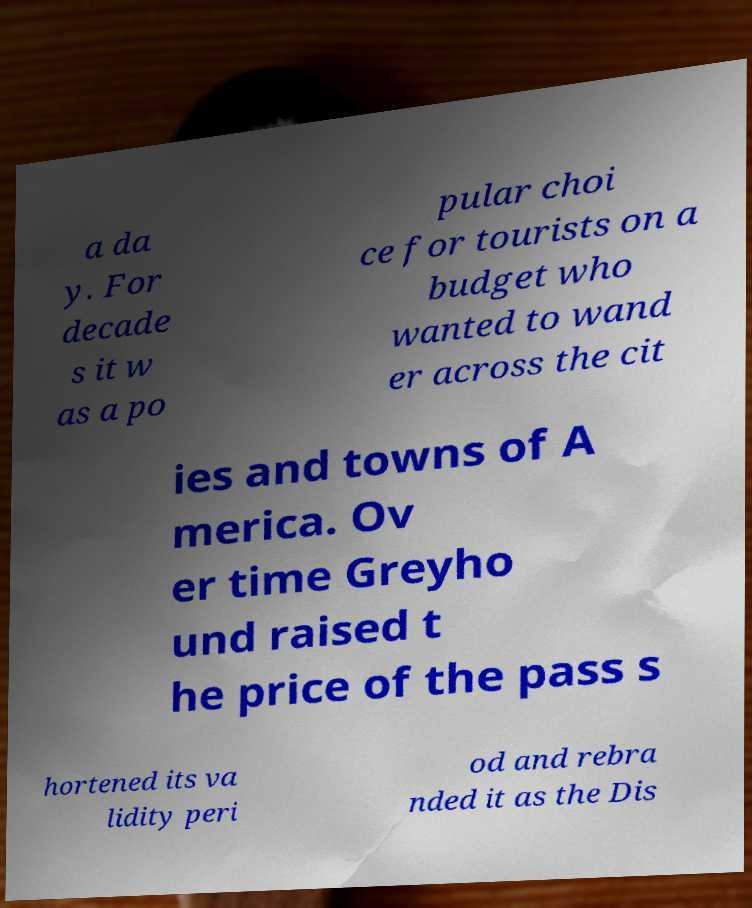Please read and relay the text visible in this image. What does it say? a da y. For decade s it w as a po pular choi ce for tourists on a budget who wanted to wand er across the cit ies and towns of A merica. Ov er time Greyho und raised t he price of the pass s hortened its va lidity peri od and rebra nded it as the Dis 